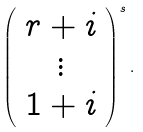Convert formula to latex. <formula><loc_0><loc_0><loc_500><loc_500>\left ( \begin{array} { c } r + i \\ \vdots \\ 1 + i \end{array} \right ) ^ { s } .</formula> 